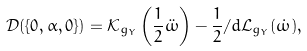<formula> <loc_0><loc_0><loc_500><loc_500>\mathcal { D } ( \{ 0 , \alpha , 0 \} ) = \mathcal { K } _ { g _ { Y } } \left ( \frac { 1 } { 2 } \ddot { \omega } \right ) - \frac { 1 } { 2 } \slash d \mathcal { L } _ { g _ { Y } } ( \dot { \omega } ) ,</formula> 